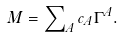<formula> <loc_0><loc_0><loc_500><loc_500>M = \sum \nolimits _ { A } c _ { A } \Gamma ^ { A } .</formula> 